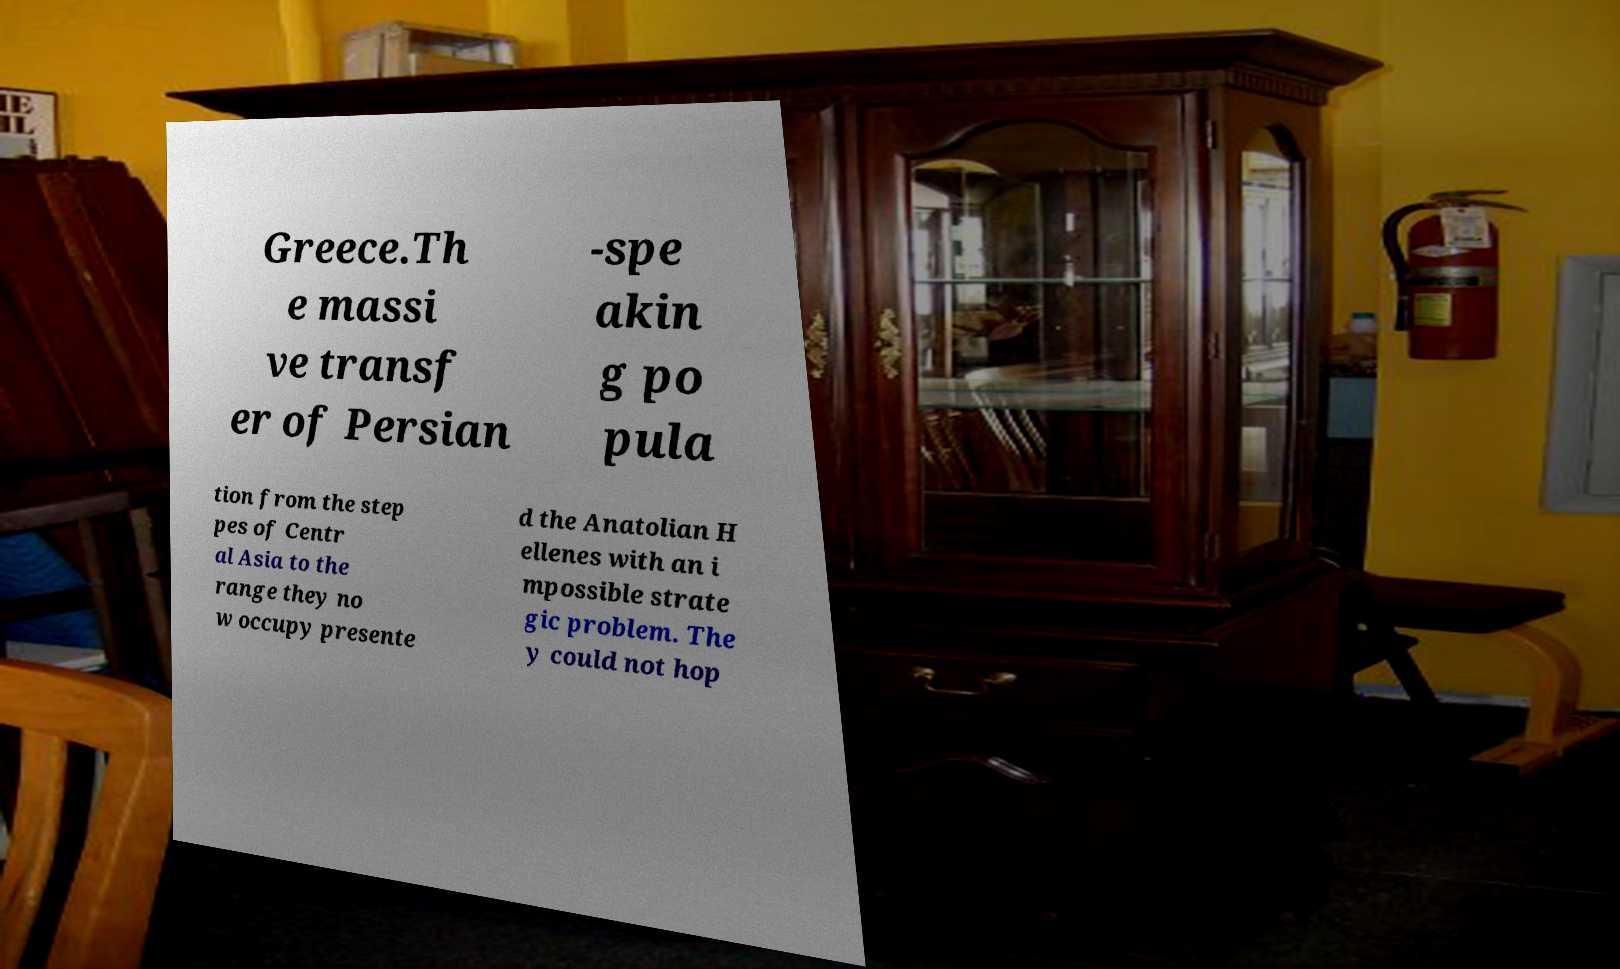Can you accurately transcribe the text from the provided image for me? Greece.Th e massi ve transf er of Persian -spe akin g po pula tion from the step pes of Centr al Asia to the range they no w occupy presente d the Anatolian H ellenes with an i mpossible strate gic problem. The y could not hop 